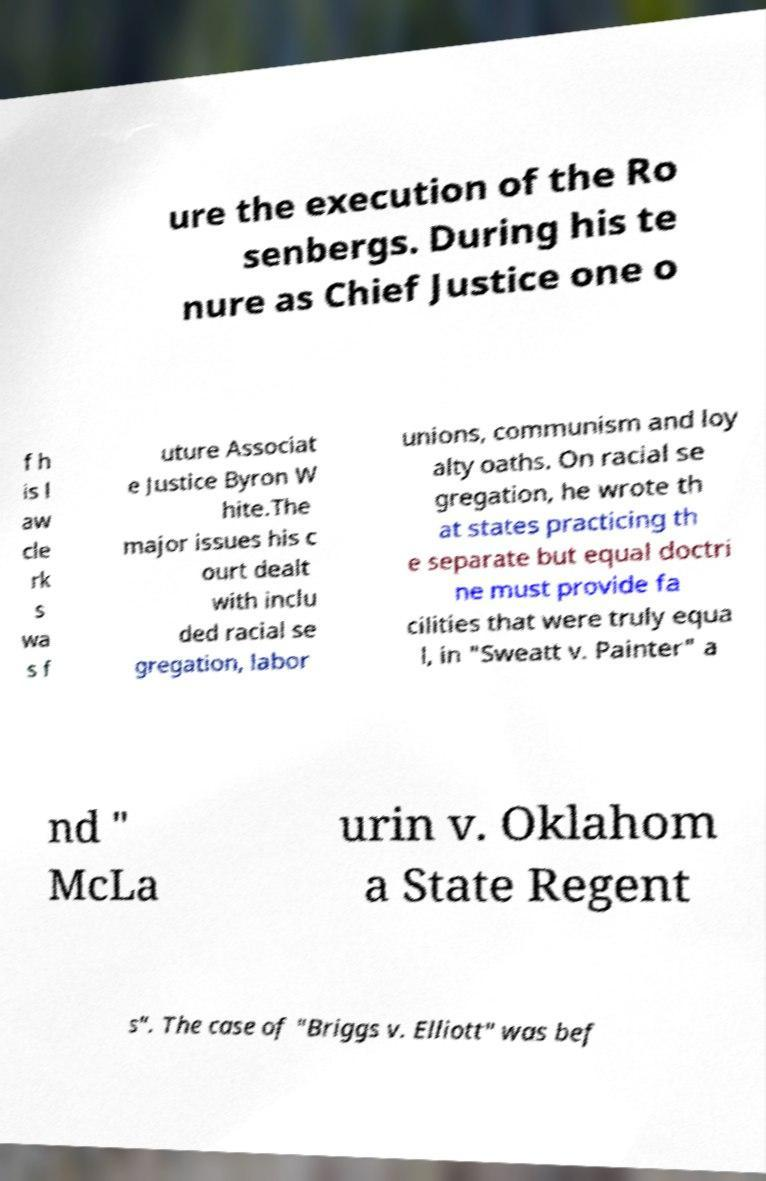Could you extract and type out the text from this image? ure the execution of the Ro senbergs. During his te nure as Chief Justice one o f h is l aw cle rk s wa s f uture Associat e Justice Byron W hite.The major issues his c ourt dealt with inclu ded racial se gregation, labor unions, communism and loy alty oaths. On racial se gregation, he wrote th at states practicing th e separate but equal doctri ne must provide fa cilities that were truly equa l, in "Sweatt v. Painter" a nd " McLa urin v. Oklahom a State Regent s". The case of "Briggs v. Elliott" was bef 